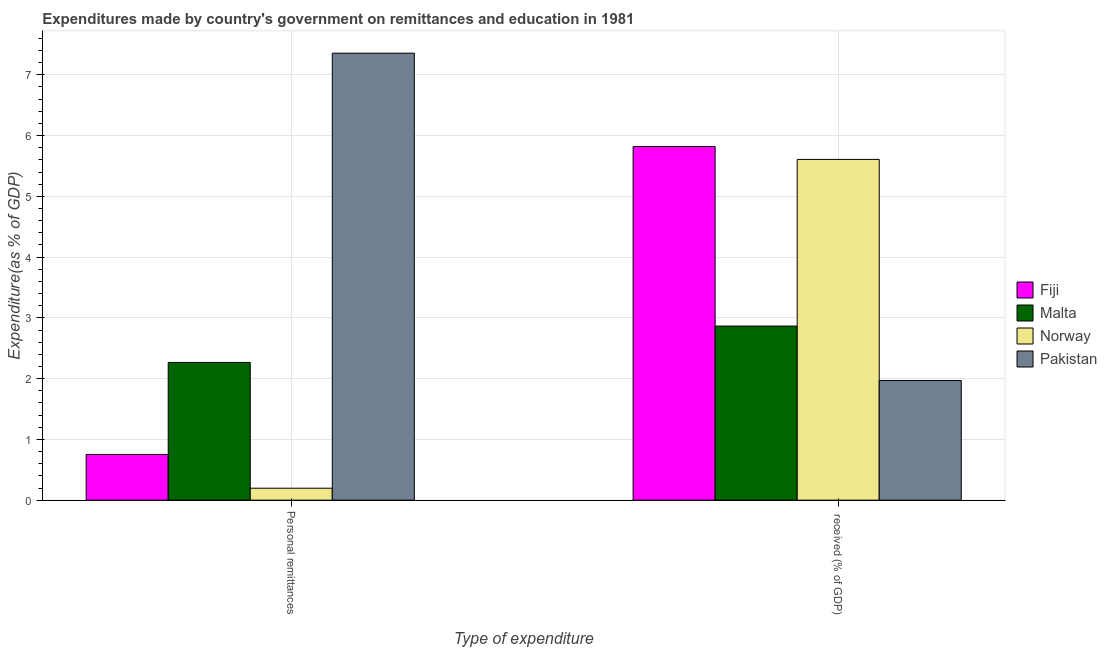How many groups of bars are there?
Provide a succinct answer. 2. Are the number of bars per tick equal to the number of legend labels?
Offer a very short reply. Yes. Are the number of bars on each tick of the X-axis equal?
Offer a very short reply. Yes. How many bars are there on the 2nd tick from the left?
Offer a terse response. 4. How many bars are there on the 1st tick from the right?
Provide a short and direct response. 4. What is the label of the 1st group of bars from the left?
Offer a very short reply. Personal remittances. What is the expenditure in education in Malta?
Your response must be concise. 2.87. Across all countries, what is the maximum expenditure in education?
Offer a very short reply. 5.82. Across all countries, what is the minimum expenditure in personal remittances?
Your answer should be very brief. 0.2. In which country was the expenditure in education maximum?
Keep it short and to the point. Fiji. What is the total expenditure in personal remittances in the graph?
Offer a terse response. 10.57. What is the difference between the expenditure in personal remittances in Malta and that in Norway?
Offer a terse response. 2.07. What is the difference between the expenditure in education in Pakistan and the expenditure in personal remittances in Malta?
Provide a short and direct response. -0.3. What is the average expenditure in personal remittances per country?
Your answer should be compact. 2.64. What is the difference between the expenditure in personal remittances and expenditure in education in Norway?
Your answer should be very brief. -5.41. What is the ratio of the expenditure in personal remittances in Pakistan to that in Malta?
Ensure brevity in your answer.  3.25. What does the 1st bar from the left in Personal remittances represents?
Offer a very short reply. Fiji. What does the 3rd bar from the right in Personal remittances represents?
Ensure brevity in your answer.  Malta. How many bars are there?
Ensure brevity in your answer.  8. Are all the bars in the graph horizontal?
Provide a short and direct response. No. Are the values on the major ticks of Y-axis written in scientific E-notation?
Keep it short and to the point. No. Where does the legend appear in the graph?
Provide a short and direct response. Center right. What is the title of the graph?
Your answer should be very brief. Expenditures made by country's government on remittances and education in 1981. Does "OECD members" appear as one of the legend labels in the graph?
Make the answer very short. No. What is the label or title of the X-axis?
Offer a terse response. Type of expenditure. What is the label or title of the Y-axis?
Provide a short and direct response. Expenditure(as % of GDP). What is the Expenditure(as % of GDP) of Fiji in Personal remittances?
Make the answer very short. 0.75. What is the Expenditure(as % of GDP) in Malta in Personal remittances?
Your answer should be compact. 2.27. What is the Expenditure(as % of GDP) in Norway in Personal remittances?
Give a very brief answer. 0.2. What is the Expenditure(as % of GDP) in Pakistan in Personal remittances?
Your answer should be very brief. 7.36. What is the Expenditure(as % of GDP) of Fiji in  received (% of GDP)?
Offer a terse response. 5.82. What is the Expenditure(as % of GDP) in Malta in  received (% of GDP)?
Provide a succinct answer. 2.87. What is the Expenditure(as % of GDP) in Norway in  received (% of GDP)?
Make the answer very short. 5.61. What is the Expenditure(as % of GDP) in Pakistan in  received (% of GDP)?
Your answer should be compact. 1.97. Across all Type of expenditure, what is the maximum Expenditure(as % of GDP) of Fiji?
Provide a short and direct response. 5.82. Across all Type of expenditure, what is the maximum Expenditure(as % of GDP) in Malta?
Provide a short and direct response. 2.87. Across all Type of expenditure, what is the maximum Expenditure(as % of GDP) of Norway?
Provide a succinct answer. 5.61. Across all Type of expenditure, what is the maximum Expenditure(as % of GDP) in Pakistan?
Your answer should be compact. 7.36. Across all Type of expenditure, what is the minimum Expenditure(as % of GDP) of Fiji?
Provide a short and direct response. 0.75. Across all Type of expenditure, what is the minimum Expenditure(as % of GDP) of Malta?
Provide a short and direct response. 2.27. Across all Type of expenditure, what is the minimum Expenditure(as % of GDP) in Norway?
Give a very brief answer. 0.2. Across all Type of expenditure, what is the minimum Expenditure(as % of GDP) in Pakistan?
Ensure brevity in your answer.  1.97. What is the total Expenditure(as % of GDP) in Fiji in the graph?
Offer a very short reply. 6.57. What is the total Expenditure(as % of GDP) of Malta in the graph?
Offer a very short reply. 5.13. What is the total Expenditure(as % of GDP) of Norway in the graph?
Provide a succinct answer. 5.8. What is the total Expenditure(as % of GDP) in Pakistan in the graph?
Make the answer very short. 9.33. What is the difference between the Expenditure(as % of GDP) of Fiji in Personal remittances and that in  received (% of GDP)?
Offer a terse response. -5.07. What is the difference between the Expenditure(as % of GDP) of Malta in Personal remittances and that in  received (% of GDP)?
Ensure brevity in your answer.  -0.6. What is the difference between the Expenditure(as % of GDP) in Norway in Personal remittances and that in  received (% of GDP)?
Offer a very short reply. -5.41. What is the difference between the Expenditure(as % of GDP) of Pakistan in Personal remittances and that in  received (% of GDP)?
Your answer should be compact. 5.39. What is the difference between the Expenditure(as % of GDP) of Fiji in Personal remittances and the Expenditure(as % of GDP) of Malta in  received (% of GDP)?
Your response must be concise. -2.11. What is the difference between the Expenditure(as % of GDP) in Fiji in Personal remittances and the Expenditure(as % of GDP) in Norway in  received (% of GDP)?
Your response must be concise. -4.86. What is the difference between the Expenditure(as % of GDP) of Fiji in Personal remittances and the Expenditure(as % of GDP) of Pakistan in  received (% of GDP)?
Make the answer very short. -1.22. What is the difference between the Expenditure(as % of GDP) of Malta in Personal remittances and the Expenditure(as % of GDP) of Norway in  received (% of GDP)?
Offer a terse response. -3.34. What is the difference between the Expenditure(as % of GDP) of Malta in Personal remittances and the Expenditure(as % of GDP) of Pakistan in  received (% of GDP)?
Offer a very short reply. 0.3. What is the difference between the Expenditure(as % of GDP) in Norway in Personal remittances and the Expenditure(as % of GDP) in Pakistan in  received (% of GDP)?
Provide a short and direct response. -1.77. What is the average Expenditure(as % of GDP) in Fiji per Type of expenditure?
Your answer should be compact. 3.29. What is the average Expenditure(as % of GDP) in Malta per Type of expenditure?
Provide a short and direct response. 2.57. What is the average Expenditure(as % of GDP) in Norway per Type of expenditure?
Make the answer very short. 2.9. What is the average Expenditure(as % of GDP) of Pakistan per Type of expenditure?
Your answer should be very brief. 4.66. What is the difference between the Expenditure(as % of GDP) in Fiji and Expenditure(as % of GDP) in Malta in Personal remittances?
Provide a short and direct response. -1.51. What is the difference between the Expenditure(as % of GDP) of Fiji and Expenditure(as % of GDP) of Norway in Personal remittances?
Offer a terse response. 0.56. What is the difference between the Expenditure(as % of GDP) in Fiji and Expenditure(as % of GDP) in Pakistan in Personal remittances?
Give a very brief answer. -6.6. What is the difference between the Expenditure(as % of GDP) in Malta and Expenditure(as % of GDP) in Norway in Personal remittances?
Offer a very short reply. 2.07. What is the difference between the Expenditure(as % of GDP) in Malta and Expenditure(as % of GDP) in Pakistan in Personal remittances?
Give a very brief answer. -5.09. What is the difference between the Expenditure(as % of GDP) in Norway and Expenditure(as % of GDP) in Pakistan in Personal remittances?
Your answer should be very brief. -7.16. What is the difference between the Expenditure(as % of GDP) of Fiji and Expenditure(as % of GDP) of Malta in  received (% of GDP)?
Provide a short and direct response. 2.95. What is the difference between the Expenditure(as % of GDP) of Fiji and Expenditure(as % of GDP) of Norway in  received (% of GDP)?
Offer a very short reply. 0.21. What is the difference between the Expenditure(as % of GDP) of Fiji and Expenditure(as % of GDP) of Pakistan in  received (% of GDP)?
Offer a very short reply. 3.85. What is the difference between the Expenditure(as % of GDP) of Malta and Expenditure(as % of GDP) of Norway in  received (% of GDP)?
Your response must be concise. -2.74. What is the difference between the Expenditure(as % of GDP) in Malta and Expenditure(as % of GDP) in Pakistan in  received (% of GDP)?
Offer a very short reply. 0.9. What is the difference between the Expenditure(as % of GDP) in Norway and Expenditure(as % of GDP) in Pakistan in  received (% of GDP)?
Offer a very short reply. 3.64. What is the ratio of the Expenditure(as % of GDP) of Fiji in Personal remittances to that in  received (% of GDP)?
Your response must be concise. 0.13. What is the ratio of the Expenditure(as % of GDP) of Malta in Personal remittances to that in  received (% of GDP)?
Make the answer very short. 0.79. What is the ratio of the Expenditure(as % of GDP) of Norway in Personal remittances to that in  received (% of GDP)?
Your response must be concise. 0.04. What is the ratio of the Expenditure(as % of GDP) in Pakistan in Personal remittances to that in  received (% of GDP)?
Your answer should be compact. 3.73. What is the difference between the highest and the second highest Expenditure(as % of GDP) of Fiji?
Offer a very short reply. 5.07. What is the difference between the highest and the second highest Expenditure(as % of GDP) of Malta?
Your answer should be compact. 0.6. What is the difference between the highest and the second highest Expenditure(as % of GDP) of Norway?
Provide a succinct answer. 5.41. What is the difference between the highest and the second highest Expenditure(as % of GDP) in Pakistan?
Ensure brevity in your answer.  5.39. What is the difference between the highest and the lowest Expenditure(as % of GDP) in Fiji?
Your response must be concise. 5.07. What is the difference between the highest and the lowest Expenditure(as % of GDP) of Malta?
Your answer should be compact. 0.6. What is the difference between the highest and the lowest Expenditure(as % of GDP) in Norway?
Offer a very short reply. 5.41. What is the difference between the highest and the lowest Expenditure(as % of GDP) in Pakistan?
Your answer should be very brief. 5.39. 